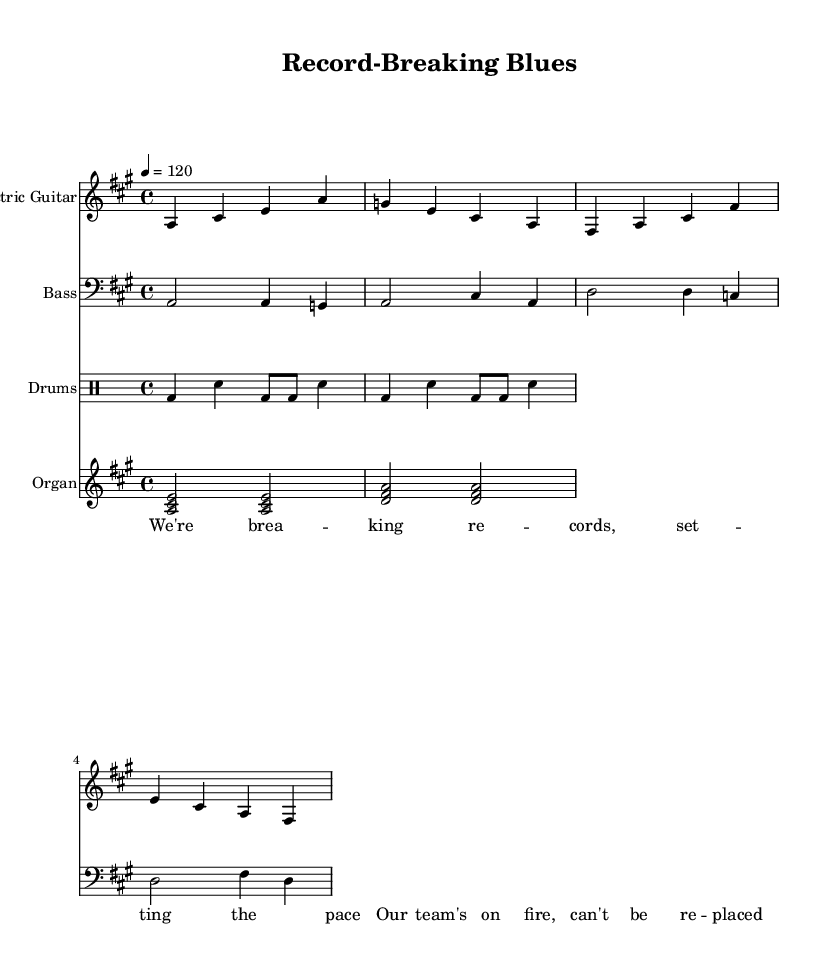What is the key signature of this music? The key signature indicates the key of A major, which is denoted by three sharps (F#, C#, G#).
Answer: A major What is the time signature of this music? The time signature is 4/4, which is indicated at the beginning of the score, meaning there are four beats per measure and the quarter note gets one beat.
Answer: 4/4 What is the tempo marking of this music? The tempo marking is indicated as "4 = 120," meaning there are 120 beats per minute. This is a fast-paced tempo typical for energetic music like electric blues.
Answer: 120 How many measures are shown for the electric guitar part? The electric guitar part has four measures, as indicated by the grouping of notes and bars.
Answer: Four What is the lyrical theme of the song? The lyrics suggest themes of victory and record-breaking accomplishments, with phrases like "breaking records" and "team's on fire." This is a common theme in sports-related anthems.
Answer: Victory and record-breaking What instruments are featured in this piece? The instruments featured include electric guitar, bass guitar, drums, and organ, as labeled in each staff of the sheet music.
Answer: Electric guitar, bass guitar, drums, organ How many different drum patterns are presented in the drum part? The drum part presents two different patterns, as shown by the two measures of drum notation.
Answer: Two 